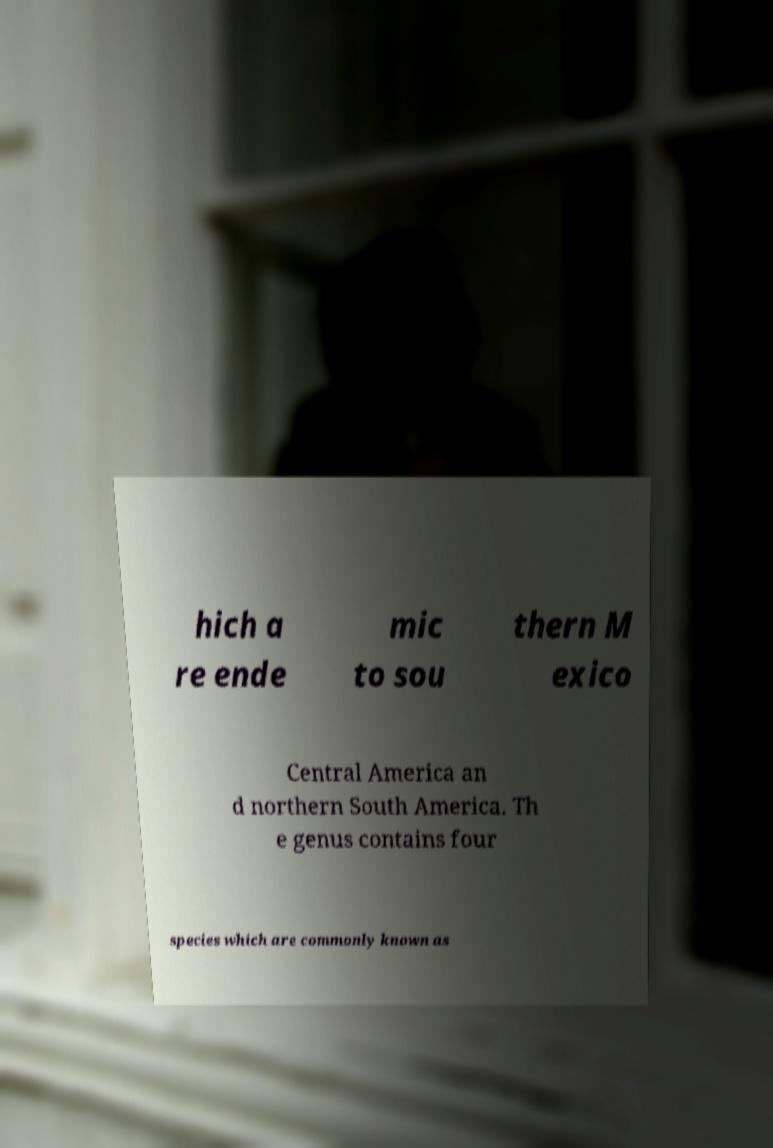Please read and relay the text visible in this image. What does it say? hich a re ende mic to sou thern M exico Central America an d northern South America. Th e genus contains four species which are commonly known as 